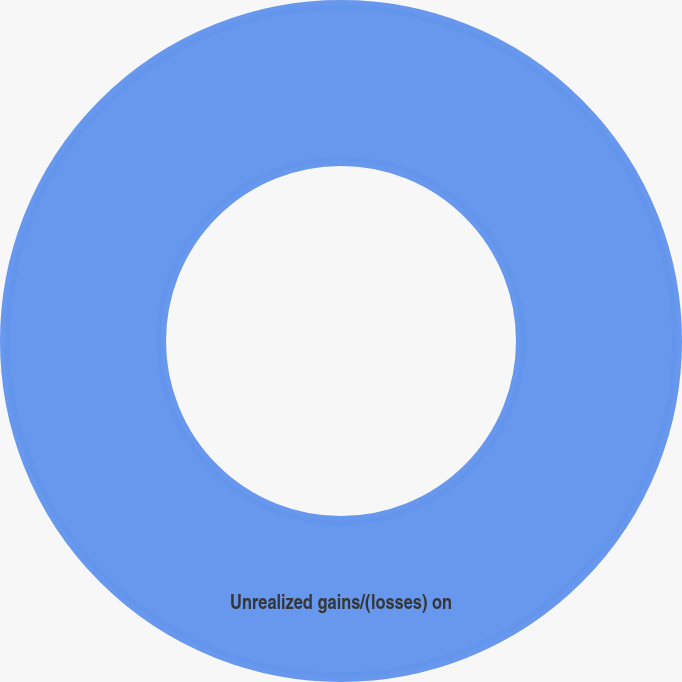Convert chart to OTSL. <chart><loc_0><loc_0><loc_500><loc_500><pie_chart><fcel>Unrealized gains/(losses) on<nl><fcel>100.0%<nl></chart> 